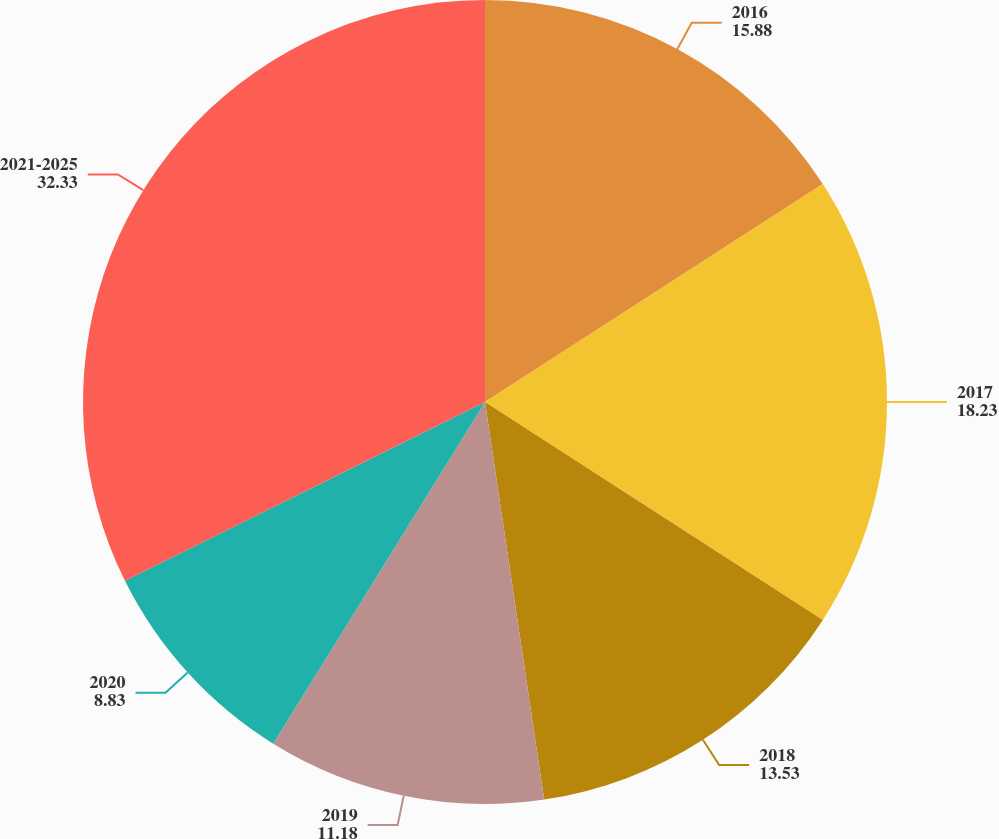<chart> <loc_0><loc_0><loc_500><loc_500><pie_chart><fcel>2016<fcel>2017<fcel>2018<fcel>2019<fcel>2020<fcel>2021-2025<nl><fcel>15.88%<fcel>18.23%<fcel>13.53%<fcel>11.18%<fcel>8.83%<fcel>32.33%<nl></chart> 